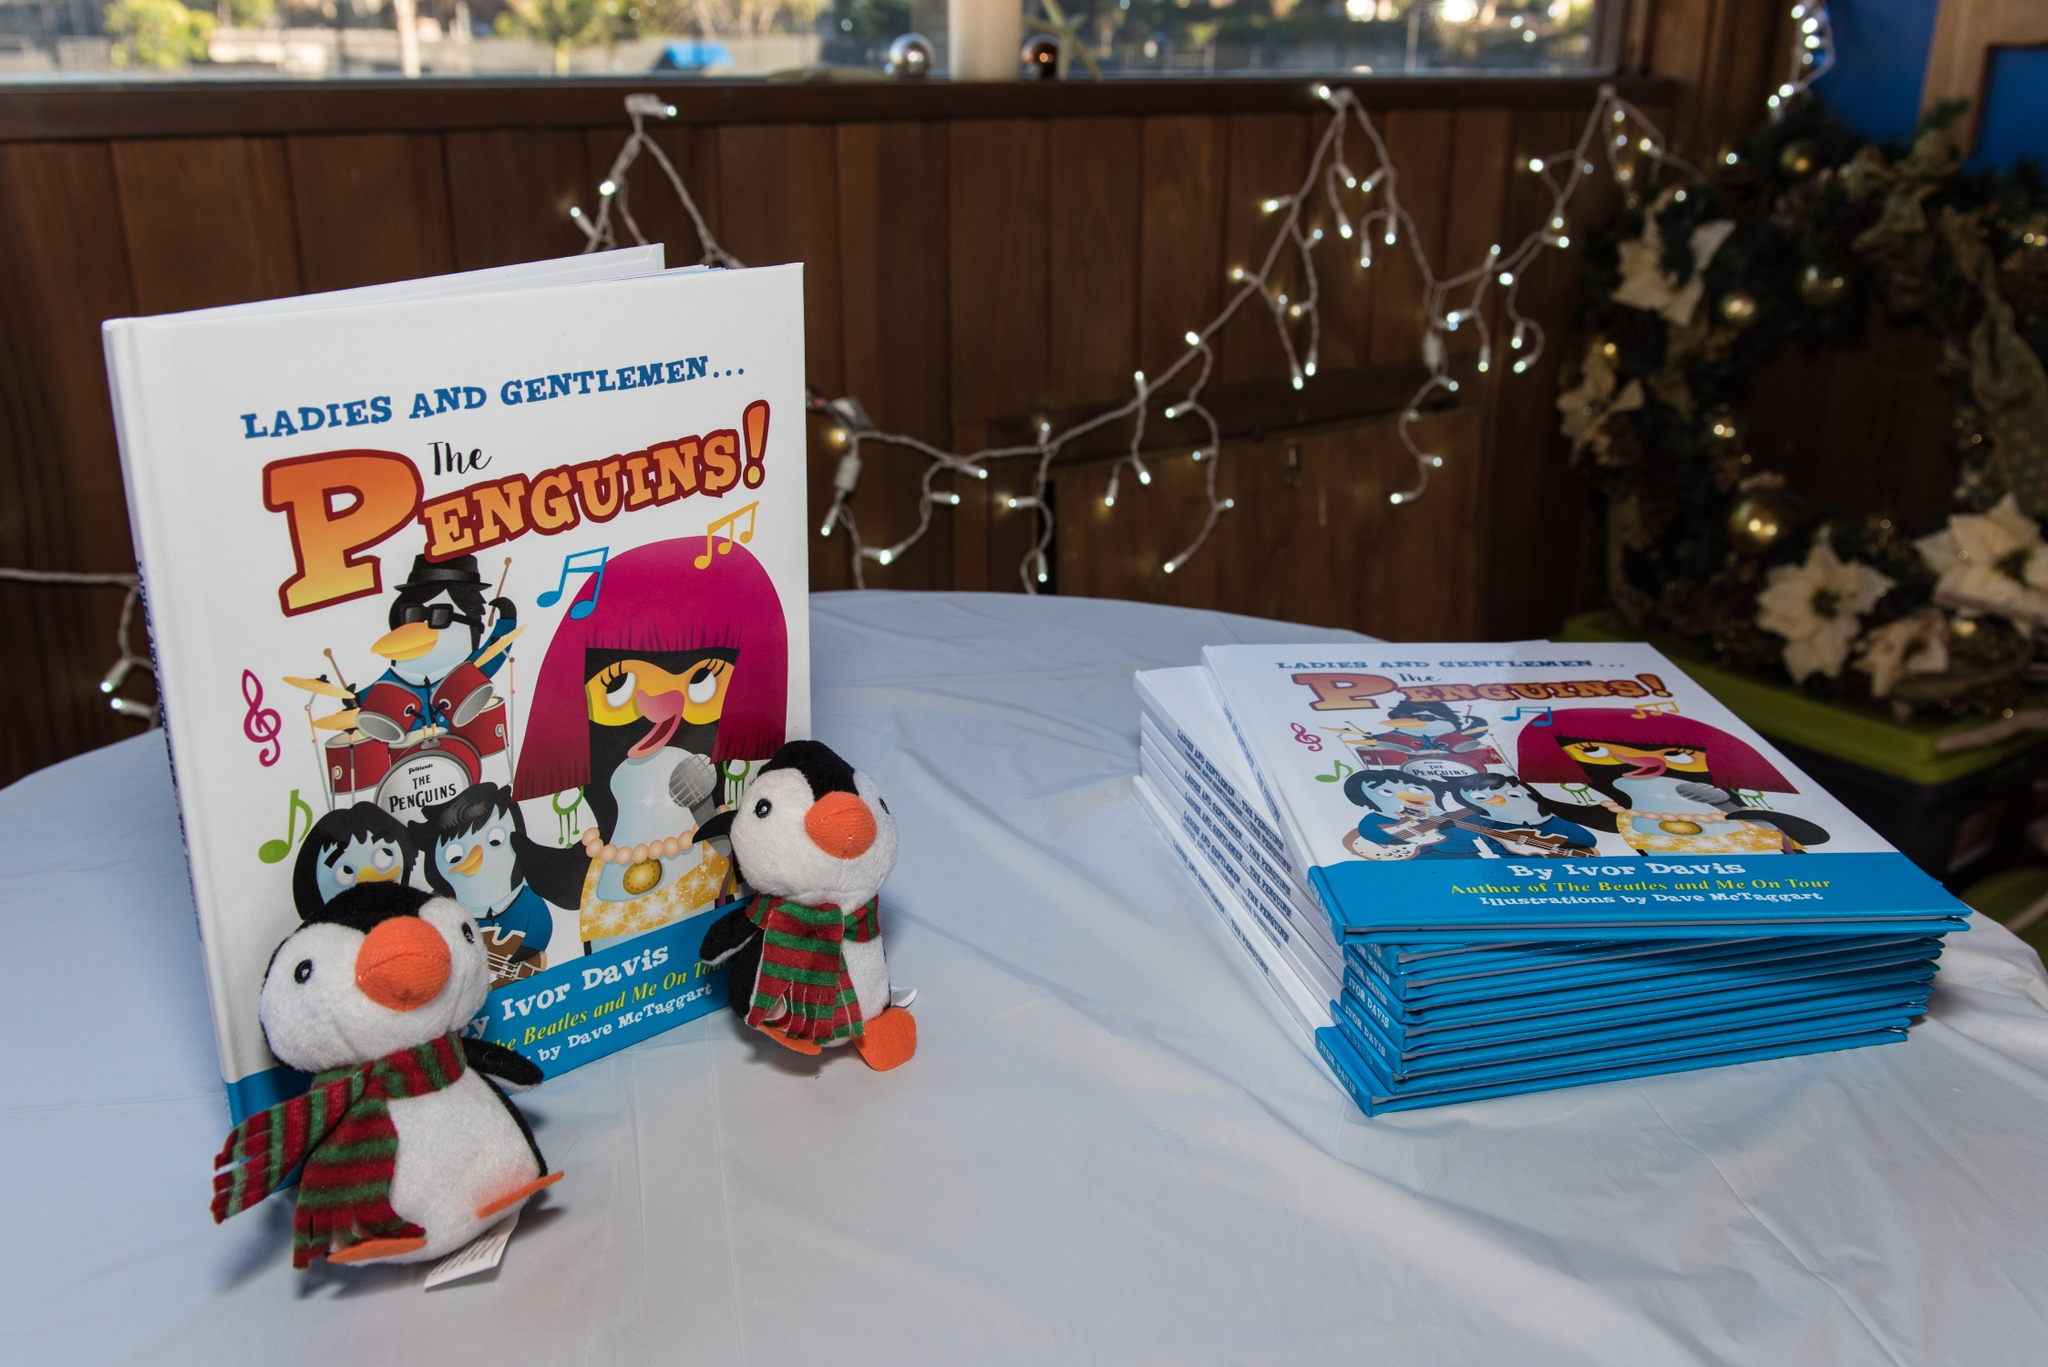What’s the occasion depicted in this photo? This photo appears to be taken at a book signing or promotional event for a children's book named 'Ladies and Gentlemen... The Penguins!' The plush penguins and festive decorations suggest it could be a holiday-themed gathering or a launch event designed to attract a young audience. Are there any specific details on the book cover that stand out? Yes, the cover features distinct cartoon-style illustrations of penguin characters portraying a musical band. A female penguin with a stylish pink haircut emerges as the lead singer, and other penguins play instruments such as a guitar and drums. The playful nature of the design, complete with musical notes and a vibrant color palette, seems to target a younger audience and denotes a fun, engaging story inside. 